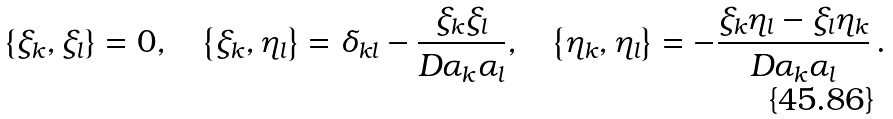<formula> <loc_0><loc_0><loc_500><loc_500>\left \{ \xi _ { k } , \xi _ { l } \right \} = 0 , \quad \left \{ \xi _ { k } , \eta _ { l } \right \} = \delta _ { k l } - \frac { \xi _ { k } \xi _ { l } } { D \alpha _ { k } \alpha _ { l } } , \quad \left \{ \eta _ { k } , \eta _ { l } \right \} = - \frac { \xi _ { k } \eta _ { l } - \xi _ { l } \eta _ { k } } { D \alpha _ { k } \alpha _ { l } } \, .</formula> 